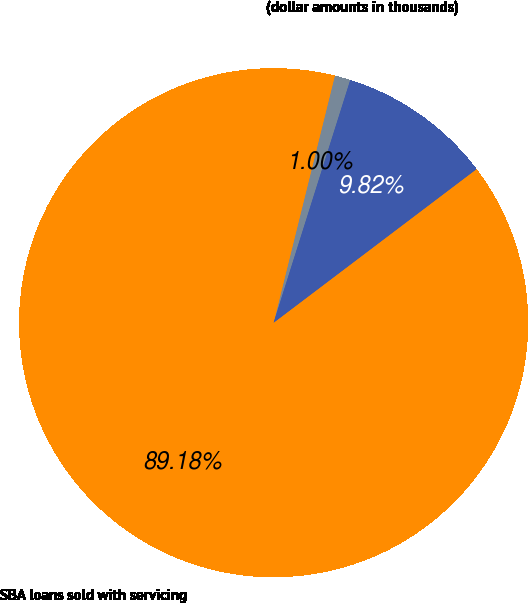Convert chart. <chart><loc_0><loc_0><loc_500><loc_500><pie_chart><fcel>(dollar amounts in thousands)<fcel>SBA loans sold with servicing<fcel>Pretax gains resulting from<nl><fcel>1.0%<fcel>89.18%<fcel>9.82%<nl></chart> 